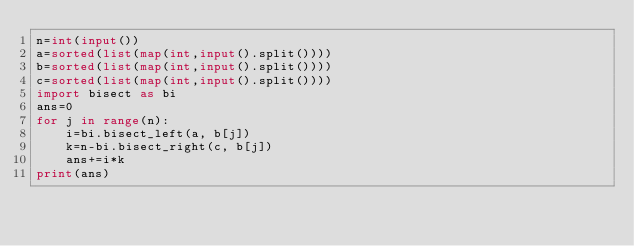Convert code to text. <code><loc_0><loc_0><loc_500><loc_500><_Python_>n=int(input())
a=sorted(list(map(int,input().split())))
b=sorted(list(map(int,input().split())))
c=sorted(list(map(int,input().split())))
import bisect as bi
ans=0
for j in range(n):
    i=bi.bisect_left(a, b[j])
    k=n-bi.bisect_right(c, b[j])
    ans+=i*k
print(ans)</code> 